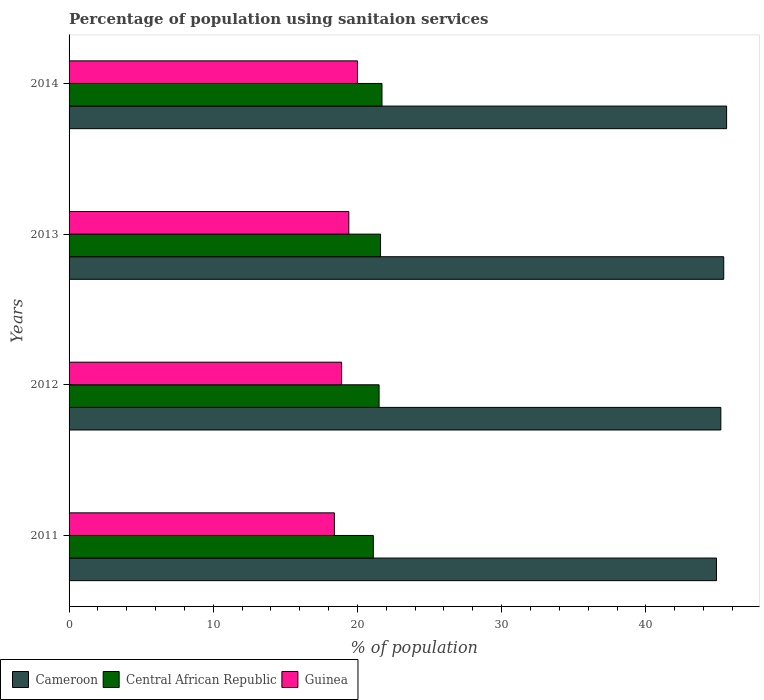Are the number of bars per tick equal to the number of legend labels?
Make the answer very short. Yes. How many bars are there on the 4th tick from the top?
Offer a very short reply. 3. How many bars are there on the 4th tick from the bottom?
Offer a very short reply. 3. Across all years, what is the maximum percentage of population using sanitaion services in Central African Republic?
Keep it short and to the point. 21.7. Across all years, what is the minimum percentage of population using sanitaion services in Cameroon?
Your answer should be compact. 44.9. What is the total percentage of population using sanitaion services in Central African Republic in the graph?
Your answer should be very brief. 85.9. What is the difference between the percentage of population using sanitaion services in Guinea in 2012 and that in 2013?
Offer a terse response. -0.5. What is the difference between the percentage of population using sanitaion services in Cameroon in 2011 and the percentage of population using sanitaion services in Central African Republic in 2012?
Offer a terse response. 23.4. What is the average percentage of population using sanitaion services in Guinea per year?
Your answer should be very brief. 19.17. In the year 2012, what is the difference between the percentage of population using sanitaion services in Guinea and percentage of population using sanitaion services in Cameroon?
Provide a succinct answer. -26.3. In how many years, is the percentage of population using sanitaion services in Cameroon greater than 18 %?
Ensure brevity in your answer.  4. What is the ratio of the percentage of population using sanitaion services in Guinea in 2011 to that in 2014?
Provide a succinct answer. 0.92. Is the percentage of population using sanitaion services in Cameroon in 2011 less than that in 2014?
Offer a very short reply. Yes. Is the difference between the percentage of population using sanitaion services in Guinea in 2011 and 2014 greater than the difference between the percentage of population using sanitaion services in Cameroon in 2011 and 2014?
Give a very brief answer. No. What is the difference between the highest and the second highest percentage of population using sanitaion services in Cameroon?
Keep it short and to the point. 0.2. What is the difference between the highest and the lowest percentage of population using sanitaion services in Cameroon?
Give a very brief answer. 0.7. Is the sum of the percentage of population using sanitaion services in Cameroon in 2012 and 2013 greater than the maximum percentage of population using sanitaion services in Guinea across all years?
Provide a succinct answer. Yes. What does the 3rd bar from the top in 2013 represents?
Your answer should be compact. Cameroon. What does the 1st bar from the bottom in 2014 represents?
Provide a succinct answer. Cameroon. Are all the bars in the graph horizontal?
Keep it short and to the point. Yes. How many years are there in the graph?
Your answer should be very brief. 4. Where does the legend appear in the graph?
Keep it short and to the point. Bottom left. What is the title of the graph?
Make the answer very short. Percentage of population using sanitaion services. Does "Jordan" appear as one of the legend labels in the graph?
Ensure brevity in your answer.  No. What is the label or title of the X-axis?
Provide a short and direct response. % of population. What is the label or title of the Y-axis?
Provide a short and direct response. Years. What is the % of population in Cameroon in 2011?
Ensure brevity in your answer.  44.9. What is the % of population in Central African Republic in 2011?
Your answer should be very brief. 21.1. What is the % of population in Cameroon in 2012?
Give a very brief answer. 45.2. What is the % of population of Central African Republic in 2012?
Provide a short and direct response. 21.5. What is the % of population of Cameroon in 2013?
Provide a short and direct response. 45.4. What is the % of population in Central African Republic in 2013?
Make the answer very short. 21.6. What is the % of population of Cameroon in 2014?
Your response must be concise. 45.6. What is the % of population of Central African Republic in 2014?
Offer a terse response. 21.7. What is the % of population of Guinea in 2014?
Provide a succinct answer. 20. Across all years, what is the maximum % of population in Cameroon?
Keep it short and to the point. 45.6. Across all years, what is the maximum % of population in Central African Republic?
Make the answer very short. 21.7. Across all years, what is the minimum % of population of Cameroon?
Make the answer very short. 44.9. Across all years, what is the minimum % of population in Central African Republic?
Give a very brief answer. 21.1. What is the total % of population in Cameroon in the graph?
Make the answer very short. 181.1. What is the total % of population in Central African Republic in the graph?
Offer a very short reply. 85.9. What is the total % of population of Guinea in the graph?
Your answer should be compact. 76.7. What is the difference between the % of population in Central African Republic in 2011 and that in 2012?
Keep it short and to the point. -0.4. What is the difference between the % of population of Guinea in 2011 and that in 2012?
Your answer should be compact. -0.5. What is the difference between the % of population of Cameroon in 2011 and that in 2013?
Offer a terse response. -0.5. What is the difference between the % of population of Cameroon in 2011 and that in 2014?
Make the answer very short. -0.7. What is the difference between the % of population in Guinea in 2011 and that in 2014?
Provide a succinct answer. -1.6. What is the difference between the % of population in Cameroon in 2012 and that in 2013?
Make the answer very short. -0.2. What is the difference between the % of population in Central African Republic in 2012 and that in 2013?
Your answer should be compact. -0.1. What is the difference between the % of population in Guinea in 2013 and that in 2014?
Give a very brief answer. -0.6. What is the difference between the % of population in Cameroon in 2011 and the % of population in Central African Republic in 2012?
Offer a very short reply. 23.4. What is the difference between the % of population in Cameroon in 2011 and the % of population in Guinea in 2012?
Offer a terse response. 26. What is the difference between the % of population of Central African Republic in 2011 and the % of population of Guinea in 2012?
Ensure brevity in your answer.  2.2. What is the difference between the % of population of Cameroon in 2011 and the % of population of Central African Republic in 2013?
Provide a short and direct response. 23.3. What is the difference between the % of population of Cameroon in 2011 and the % of population of Guinea in 2013?
Ensure brevity in your answer.  25.5. What is the difference between the % of population of Central African Republic in 2011 and the % of population of Guinea in 2013?
Make the answer very short. 1.7. What is the difference between the % of population in Cameroon in 2011 and the % of population in Central African Republic in 2014?
Your answer should be compact. 23.2. What is the difference between the % of population in Cameroon in 2011 and the % of population in Guinea in 2014?
Offer a terse response. 24.9. What is the difference between the % of population in Cameroon in 2012 and the % of population in Central African Republic in 2013?
Offer a terse response. 23.6. What is the difference between the % of population in Cameroon in 2012 and the % of population in Guinea in 2013?
Your answer should be compact. 25.8. What is the difference between the % of population in Cameroon in 2012 and the % of population in Guinea in 2014?
Offer a very short reply. 25.2. What is the difference between the % of population in Central African Republic in 2012 and the % of population in Guinea in 2014?
Provide a succinct answer. 1.5. What is the difference between the % of population of Cameroon in 2013 and the % of population of Central African Republic in 2014?
Your response must be concise. 23.7. What is the difference between the % of population in Cameroon in 2013 and the % of population in Guinea in 2014?
Make the answer very short. 25.4. What is the average % of population in Cameroon per year?
Your answer should be very brief. 45.27. What is the average % of population of Central African Republic per year?
Provide a succinct answer. 21.48. What is the average % of population of Guinea per year?
Offer a terse response. 19.18. In the year 2011, what is the difference between the % of population of Cameroon and % of population of Central African Republic?
Offer a terse response. 23.8. In the year 2011, what is the difference between the % of population of Cameroon and % of population of Guinea?
Your answer should be very brief. 26.5. In the year 2011, what is the difference between the % of population of Central African Republic and % of population of Guinea?
Your answer should be very brief. 2.7. In the year 2012, what is the difference between the % of population of Cameroon and % of population of Central African Republic?
Ensure brevity in your answer.  23.7. In the year 2012, what is the difference between the % of population in Cameroon and % of population in Guinea?
Your answer should be compact. 26.3. In the year 2012, what is the difference between the % of population in Central African Republic and % of population in Guinea?
Ensure brevity in your answer.  2.6. In the year 2013, what is the difference between the % of population in Cameroon and % of population in Central African Republic?
Your answer should be compact. 23.8. In the year 2014, what is the difference between the % of population in Cameroon and % of population in Central African Republic?
Offer a terse response. 23.9. In the year 2014, what is the difference between the % of population in Cameroon and % of population in Guinea?
Provide a short and direct response. 25.6. What is the ratio of the % of population in Cameroon in 2011 to that in 2012?
Keep it short and to the point. 0.99. What is the ratio of the % of population in Central African Republic in 2011 to that in 2012?
Keep it short and to the point. 0.98. What is the ratio of the % of population of Guinea in 2011 to that in 2012?
Keep it short and to the point. 0.97. What is the ratio of the % of population of Central African Republic in 2011 to that in 2013?
Offer a terse response. 0.98. What is the ratio of the % of population in Guinea in 2011 to that in 2013?
Offer a terse response. 0.95. What is the ratio of the % of population of Cameroon in 2011 to that in 2014?
Give a very brief answer. 0.98. What is the ratio of the % of population of Central African Republic in 2011 to that in 2014?
Provide a short and direct response. 0.97. What is the ratio of the % of population of Guinea in 2011 to that in 2014?
Keep it short and to the point. 0.92. What is the ratio of the % of population of Central African Republic in 2012 to that in 2013?
Provide a short and direct response. 1. What is the ratio of the % of population of Guinea in 2012 to that in 2013?
Provide a short and direct response. 0.97. What is the ratio of the % of population in Cameroon in 2012 to that in 2014?
Keep it short and to the point. 0.99. What is the ratio of the % of population of Guinea in 2012 to that in 2014?
Provide a short and direct response. 0.94. What is the ratio of the % of population of Guinea in 2013 to that in 2014?
Offer a terse response. 0.97. What is the difference between the highest and the second highest % of population in Cameroon?
Make the answer very short. 0.2. What is the difference between the highest and the second highest % of population of Central African Republic?
Your answer should be compact. 0.1. What is the difference between the highest and the lowest % of population of Guinea?
Provide a short and direct response. 1.6. 